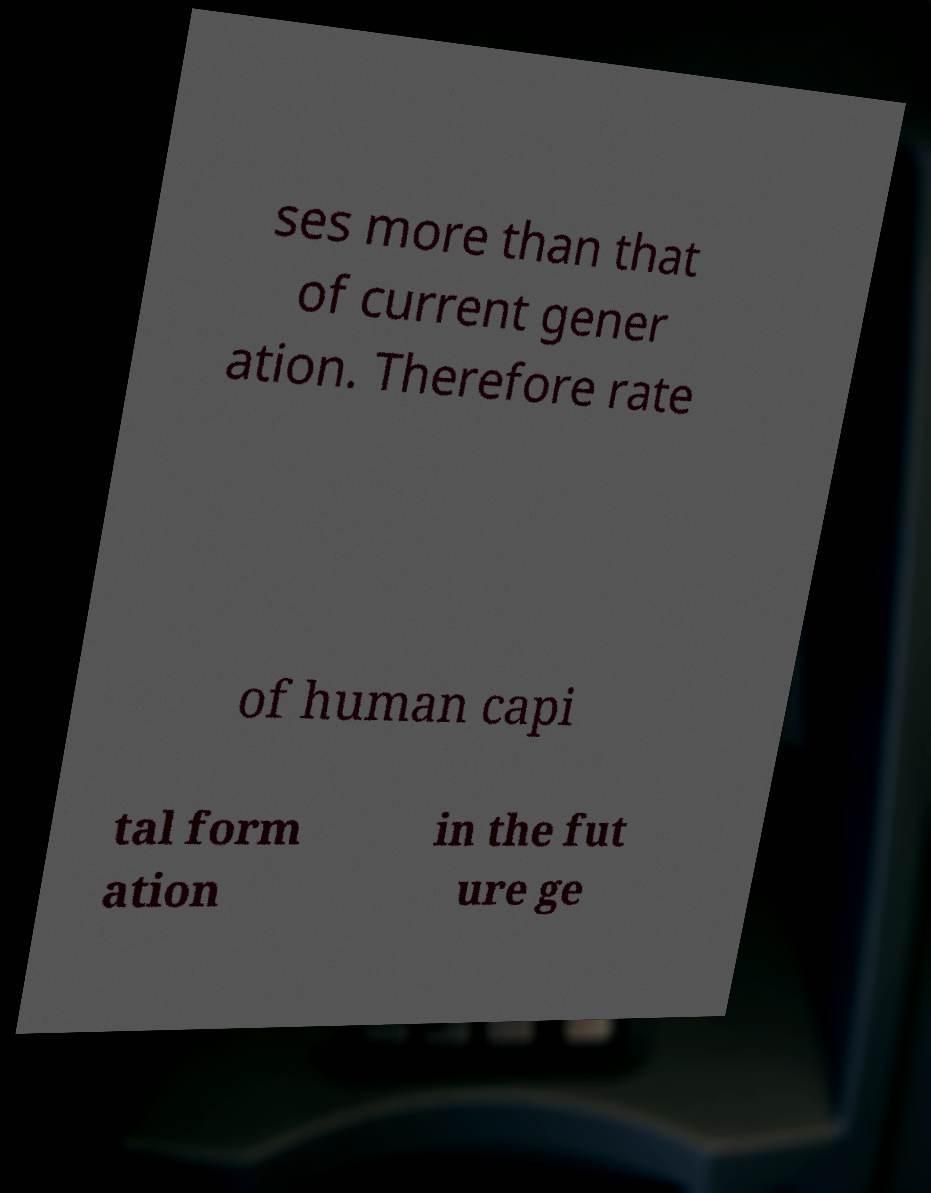There's text embedded in this image that I need extracted. Can you transcribe it verbatim? ses more than that of current gener ation. Therefore rate of human capi tal form ation in the fut ure ge 